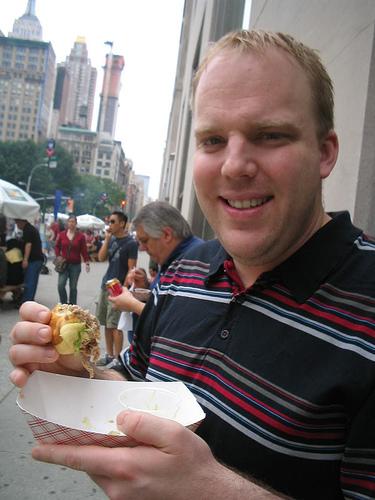Are those lady hands or man hands?
Write a very short answer. Man. Does this man have straight or curly hair?
Keep it brief. Straight. Do any men have facial hair?
Keep it brief. No. What color is the carton?
Quick response, please. Red and white. Is the man wearing glasses?
Short answer required. No. What is the man eating?
Be succinct. Hot dog. Is this inside a bar?
Be succinct. No. Has he eaten the hot dog?
Write a very short answer. Yes. 